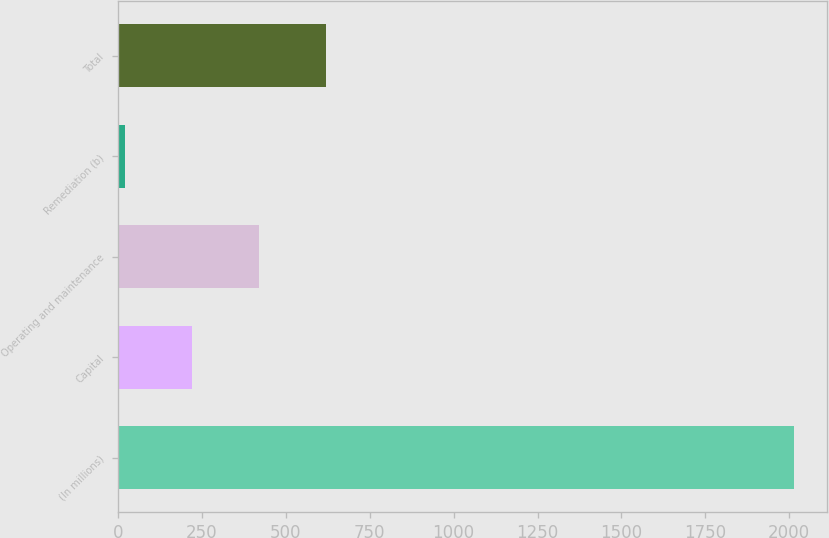Convert chart. <chart><loc_0><loc_0><loc_500><loc_500><bar_chart><fcel>(In millions)<fcel>Capital<fcel>Operating and maintenance<fcel>Remediation (b)<fcel>Total<nl><fcel>2013<fcel>221.1<fcel>420.2<fcel>22<fcel>619.3<nl></chart> 